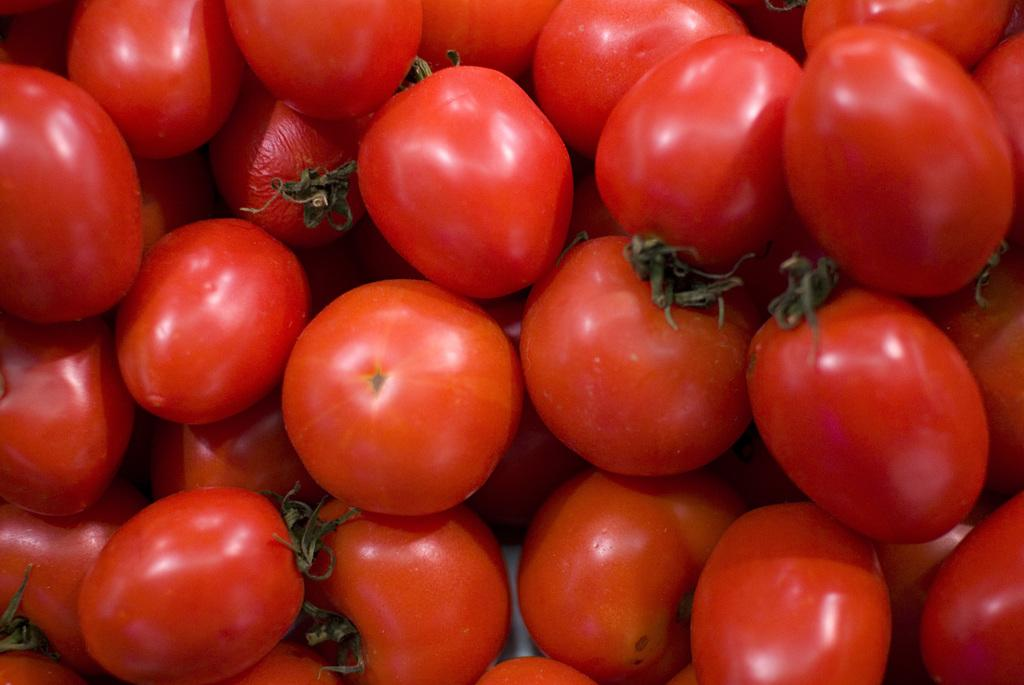What type of fruit is present in the image? There are tomatoes in the image. What color are the tomatoes? The tomatoes are red in color. How do the tomatoes compare to potatoes in the image? There are no potatoes present in the image, so a comparison cannot be made. 